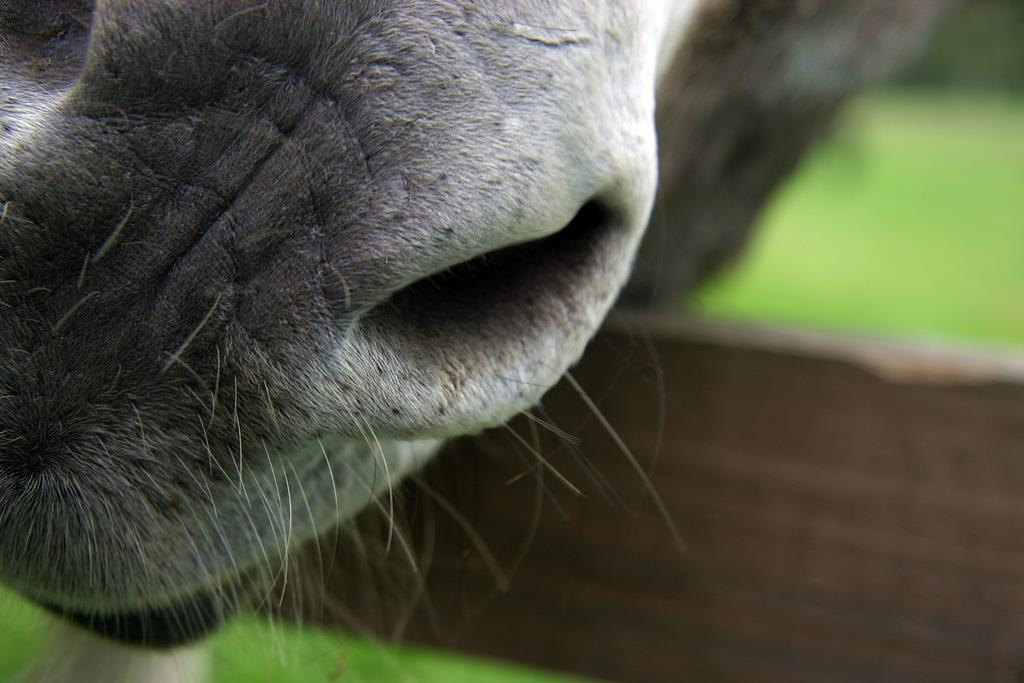What is the main subject of the image? The main subject of the image is an animal nose. Can you describe the background of the image? The background of the image is blurred. What type of waste is being disposed of in the box in the image? There is no box or waste present in the image; it only features an animal nose with a blurred background. 